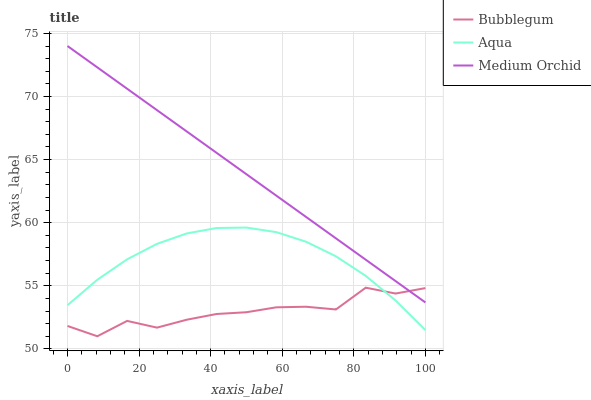Does Bubblegum have the minimum area under the curve?
Answer yes or no. Yes. Does Medium Orchid have the maximum area under the curve?
Answer yes or no. Yes. Does Aqua have the minimum area under the curve?
Answer yes or no. No. Does Aqua have the maximum area under the curve?
Answer yes or no. No. Is Medium Orchid the smoothest?
Answer yes or no. Yes. Is Bubblegum the roughest?
Answer yes or no. Yes. Is Aqua the smoothest?
Answer yes or no. No. Is Aqua the roughest?
Answer yes or no. No. Does Aqua have the lowest value?
Answer yes or no. No. Does Medium Orchid have the highest value?
Answer yes or no. Yes. Does Aqua have the highest value?
Answer yes or no. No. Is Aqua less than Medium Orchid?
Answer yes or no. Yes. Is Medium Orchid greater than Aqua?
Answer yes or no. Yes. Does Aqua intersect Medium Orchid?
Answer yes or no. No. 